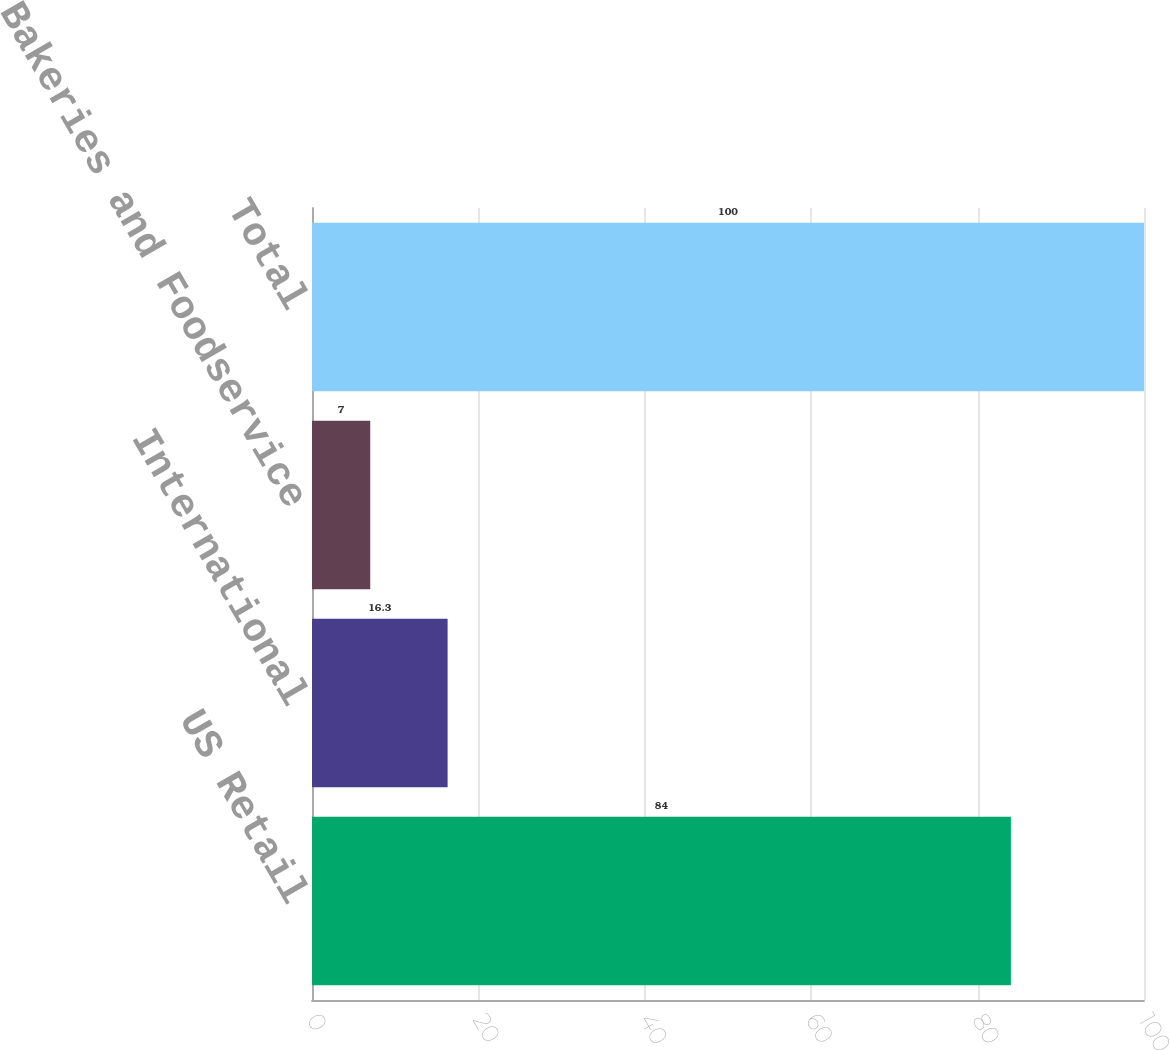Convert chart. <chart><loc_0><loc_0><loc_500><loc_500><bar_chart><fcel>US Retail<fcel>International<fcel>Bakeries and Foodservice<fcel>Total<nl><fcel>84<fcel>16.3<fcel>7<fcel>100<nl></chart> 